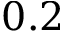Convert formula to latex. <formula><loc_0><loc_0><loc_500><loc_500>0 . 2</formula> 